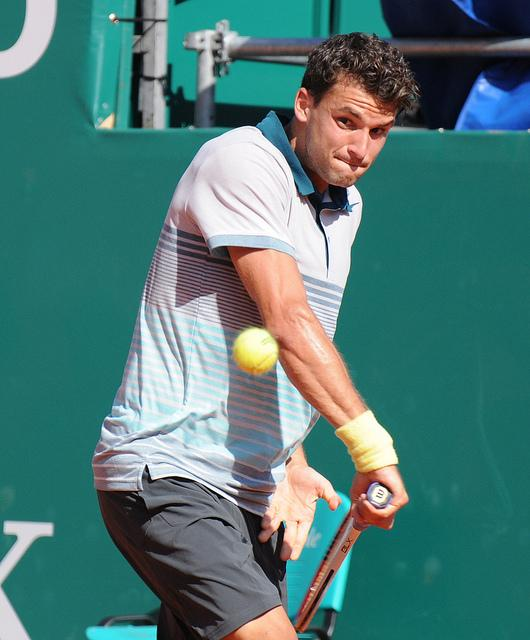What manner will the person here hit the ball? Please explain your reasoning. backhanded. The man has his tennis racket in front of him and is about to hit the ball using the forehand position. 